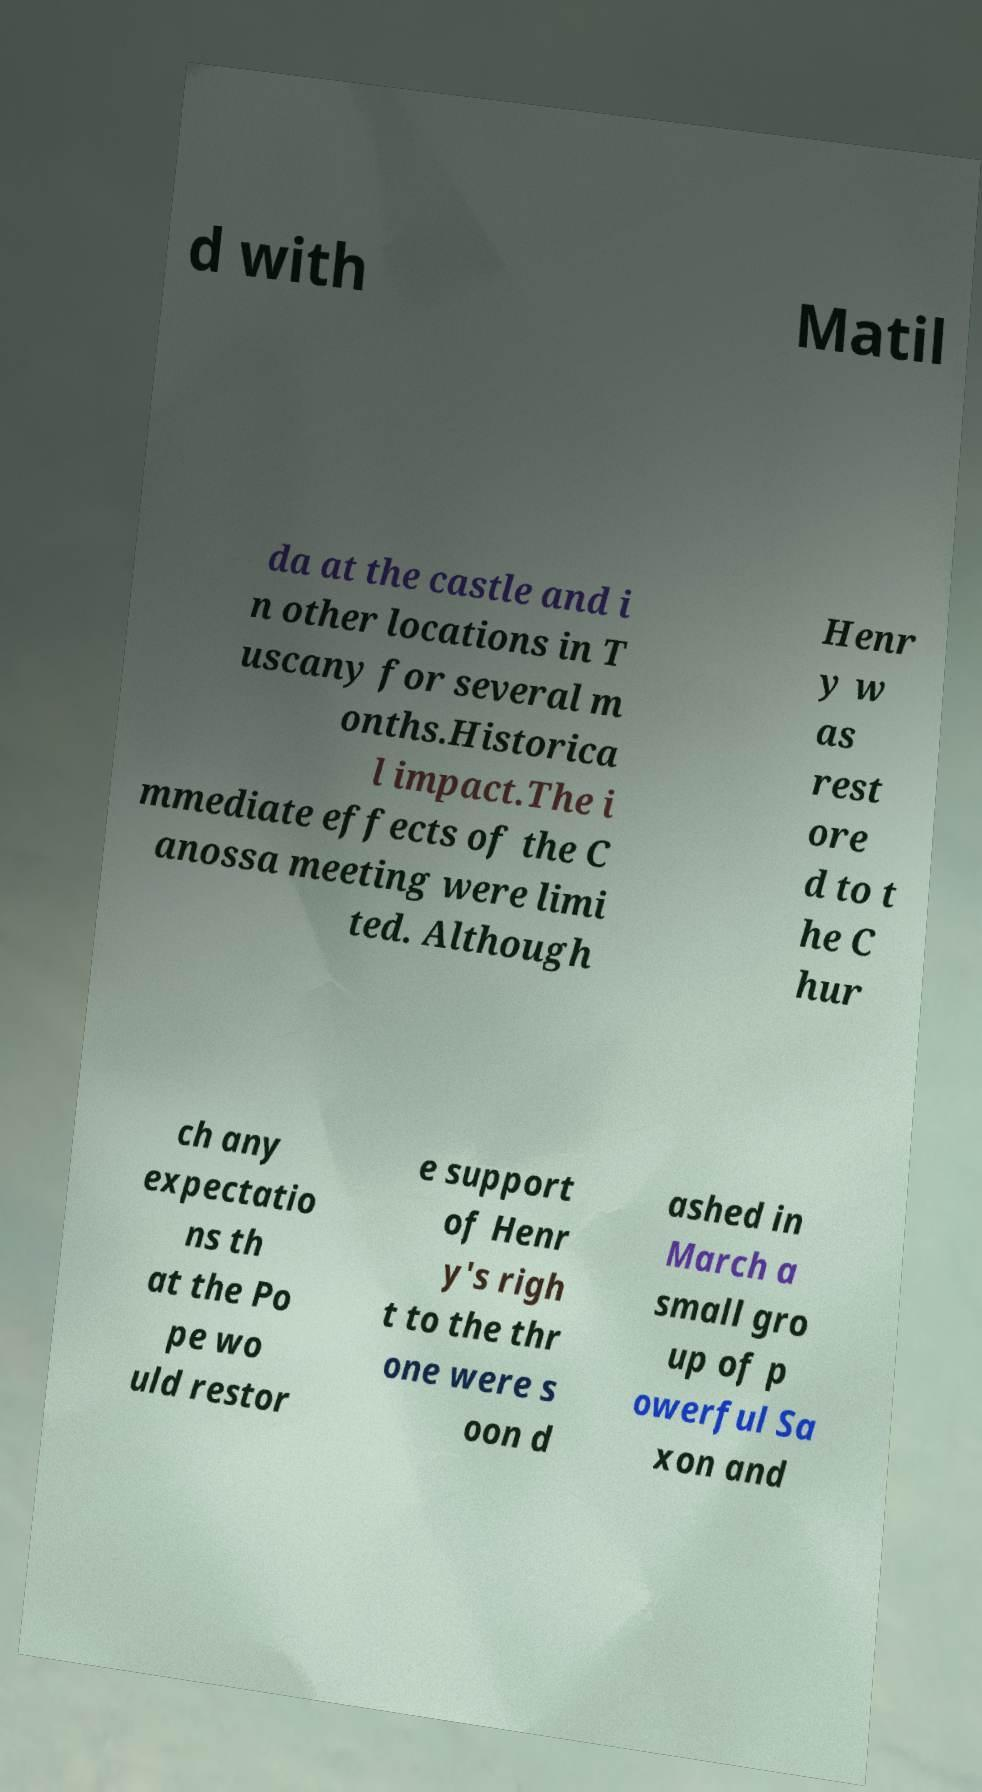Can you accurately transcribe the text from the provided image for me? d with Matil da at the castle and i n other locations in T uscany for several m onths.Historica l impact.The i mmediate effects of the C anossa meeting were limi ted. Although Henr y w as rest ore d to t he C hur ch any expectatio ns th at the Po pe wo uld restor e support of Henr y's righ t to the thr one were s oon d ashed in March a small gro up of p owerful Sa xon and 